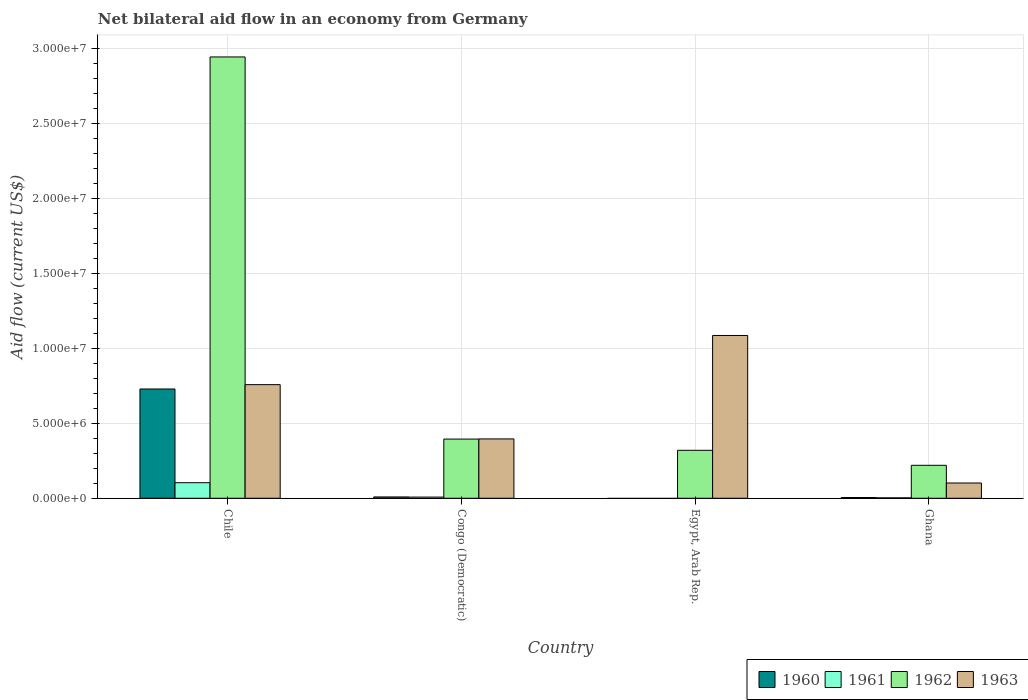How many different coloured bars are there?
Make the answer very short. 4. Are the number of bars per tick equal to the number of legend labels?
Offer a very short reply. No. How many bars are there on the 4th tick from the left?
Provide a succinct answer. 4. How many bars are there on the 1st tick from the right?
Ensure brevity in your answer.  4. What is the label of the 2nd group of bars from the left?
Offer a terse response. Congo (Democratic). What is the net bilateral aid flow in 1963 in Congo (Democratic)?
Your answer should be compact. 3.96e+06. Across all countries, what is the maximum net bilateral aid flow in 1962?
Your answer should be compact. 2.94e+07. Across all countries, what is the minimum net bilateral aid flow in 1963?
Your answer should be compact. 1.02e+06. What is the total net bilateral aid flow in 1960 in the graph?
Ensure brevity in your answer.  7.43e+06. What is the difference between the net bilateral aid flow in 1963 in Egypt, Arab Rep. and that in Ghana?
Offer a very short reply. 9.84e+06. What is the difference between the net bilateral aid flow in 1961 in Egypt, Arab Rep. and the net bilateral aid flow in 1963 in Ghana?
Make the answer very short. -1.02e+06. What is the average net bilateral aid flow in 1960 per country?
Your answer should be very brief. 1.86e+06. What is the difference between the net bilateral aid flow of/in 1962 and net bilateral aid flow of/in 1963 in Chile?
Your answer should be very brief. 2.19e+07. What is the ratio of the net bilateral aid flow in 1963 in Chile to that in Egypt, Arab Rep.?
Offer a very short reply. 0.7. Is the net bilateral aid flow in 1962 in Chile less than that in Congo (Democratic)?
Your answer should be compact. No. What is the difference between the highest and the second highest net bilateral aid flow in 1962?
Give a very brief answer. 2.62e+07. What is the difference between the highest and the lowest net bilateral aid flow in 1963?
Keep it short and to the point. 9.84e+06. In how many countries, is the net bilateral aid flow in 1960 greater than the average net bilateral aid flow in 1960 taken over all countries?
Ensure brevity in your answer.  1. Is it the case that in every country, the sum of the net bilateral aid flow in 1963 and net bilateral aid flow in 1961 is greater than the net bilateral aid flow in 1962?
Provide a succinct answer. No. How many bars are there?
Keep it short and to the point. 14. What is the difference between two consecutive major ticks on the Y-axis?
Offer a terse response. 5.00e+06. Are the values on the major ticks of Y-axis written in scientific E-notation?
Your response must be concise. Yes. Does the graph contain any zero values?
Offer a terse response. Yes. Does the graph contain grids?
Make the answer very short. Yes. What is the title of the graph?
Offer a very short reply. Net bilateral aid flow in an economy from Germany. What is the label or title of the Y-axis?
Provide a short and direct response. Aid flow (current US$). What is the Aid flow (current US$) in 1960 in Chile?
Keep it short and to the point. 7.29e+06. What is the Aid flow (current US$) in 1961 in Chile?
Keep it short and to the point. 1.04e+06. What is the Aid flow (current US$) in 1962 in Chile?
Provide a succinct answer. 2.94e+07. What is the Aid flow (current US$) in 1963 in Chile?
Offer a very short reply. 7.58e+06. What is the Aid flow (current US$) of 1962 in Congo (Democratic)?
Your answer should be compact. 3.95e+06. What is the Aid flow (current US$) in 1963 in Congo (Democratic)?
Keep it short and to the point. 3.96e+06. What is the Aid flow (current US$) in 1960 in Egypt, Arab Rep.?
Give a very brief answer. 0. What is the Aid flow (current US$) of 1961 in Egypt, Arab Rep.?
Give a very brief answer. 0. What is the Aid flow (current US$) of 1962 in Egypt, Arab Rep.?
Ensure brevity in your answer.  3.20e+06. What is the Aid flow (current US$) in 1963 in Egypt, Arab Rep.?
Your answer should be compact. 1.09e+07. What is the Aid flow (current US$) in 1961 in Ghana?
Provide a succinct answer. 3.00e+04. What is the Aid flow (current US$) in 1962 in Ghana?
Give a very brief answer. 2.20e+06. What is the Aid flow (current US$) of 1963 in Ghana?
Provide a succinct answer. 1.02e+06. Across all countries, what is the maximum Aid flow (current US$) of 1960?
Keep it short and to the point. 7.29e+06. Across all countries, what is the maximum Aid flow (current US$) of 1961?
Offer a very short reply. 1.04e+06. Across all countries, what is the maximum Aid flow (current US$) of 1962?
Give a very brief answer. 2.94e+07. Across all countries, what is the maximum Aid flow (current US$) of 1963?
Offer a very short reply. 1.09e+07. Across all countries, what is the minimum Aid flow (current US$) in 1961?
Keep it short and to the point. 0. Across all countries, what is the minimum Aid flow (current US$) of 1962?
Keep it short and to the point. 2.20e+06. Across all countries, what is the minimum Aid flow (current US$) of 1963?
Make the answer very short. 1.02e+06. What is the total Aid flow (current US$) in 1960 in the graph?
Offer a very short reply. 7.43e+06. What is the total Aid flow (current US$) of 1961 in the graph?
Provide a succinct answer. 1.15e+06. What is the total Aid flow (current US$) of 1962 in the graph?
Ensure brevity in your answer.  3.88e+07. What is the total Aid flow (current US$) of 1963 in the graph?
Provide a short and direct response. 2.34e+07. What is the difference between the Aid flow (current US$) in 1960 in Chile and that in Congo (Democratic)?
Your answer should be very brief. 7.20e+06. What is the difference between the Aid flow (current US$) of 1961 in Chile and that in Congo (Democratic)?
Your answer should be very brief. 9.60e+05. What is the difference between the Aid flow (current US$) in 1962 in Chile and that in Congo (Democratic)?
Your answer should be very brief. 2.55e+07. What is the difference between the Aid flow (current US$) in 1963 in Chile and that in Congo (Democratic)?
Keep it short and to the point. 3.62e+06. What is the difference between the Aid flow (current US$) in 1962 in Chile and that in Egypt, Arab Rep.?
Your answer should be compact. 2.62e+07. What is the difference between the Aid flow (current US$) in 1963 in Chile and that in Egypt, Arab Rep.?
Your response must be concise. -3.28e+06. What is the difference between the Aid flow (current US$) in 1960 in Chile and that in Ghana?
Offer a very short reply. 7.24e+06. What is the difference between the Aid flow (current US$) in 1961 in Chile and that in Ghana?
Provide a succinct answer. 1.01e+06. What is the difference between the Aid flow (current US$) of 1962 in Chile and that in Ghana?
Keep it short and to the point. 2.72e+07. What is the difference between the Aid flow (current US$) in 1963 in Chile and that in Ghana?
Your answer should be compact. 6.56e+06. What is the difference between the Aid flow (current US$) in 1962 in Congo (Democratic) and that in Egypt, Arab Rep.?
Your answer should be very brief. 7.50e+05. What is the difference between the Aid flow (current US$) in 1963 in Congo (Democratic) and that in Egypt, Arab Rep.?
Provide a short and direct response. -6.90e+06. What is the difference between the Aid flow (current US$) of 1960 in Congo (Democratic) and that in Ghana?
Your answer should be very brief. 4.00e+04. What is the difference between the Aid flow (current US$) in 1961 in Congo (Democratic) and that in Ghana?
Offer a very short reply. 5.00e+04. What is the difference between the Aid flow (current US$) in 1962 in Congo (Democratic) and that in Ghana?
Provide a succinct answer. 1.75e+06. What is the difference between the Aid flow (current US$) in 1963 in Congo (Democratic) and that in Ghana?
Provide a short and direct response. 2.94e+06. What is the difference between the Aid flow (current US$) in 1962 in Egypt, Arab Rep. and that in Ghana?
Provide a succinct answer. 1.00e+06. What is the difference between the Aid flow (current US$) in 1963 in Egypt, Arab Rep. and that in Ghana?
Your answer should be compact. 9.84e+06. What is the difference between the Aid flow (current US$) of 1960 in Chile and the Aid flow (current US$) of 1961 in Congo (Democratic)?
Make the answer very short. 7.21e+06. What is the difference between the Aid flow (current US$) in 1960 in Chile and the Aid flow (current US$) in 1962 in Congo (Democratic)?
Your response must be concise. 3.34e+06. What is the difference between the Aid flow (current US$) in 1960 in Chile and the Aid flow (current US$) in 1963 in Congo (Democratic)?
Ensure brevity in your answer.  3.33e+06. What is the difference between the Aid flow (current US$) in 1961 in Chile and the Aid flow (current US$) in 1962 in Congo (Democratic)?
Provide a succinct answer. -2.91e+06. What is the difference between the Aid flow (current US$) of 1961 in Chile and the Aid flow (current US$) of 1963 in Congo (Democratic)?
Provide a succinct answer. -2.92e+06. What is the difference between the Aid flow (current US$) in 1962 in Chile and the Aid flow (current US$) in 1963 in Congo (Democratic)?
Offer a terse response. 2.55e+07. What is the difference between the Aid flow (current US$) in 1960 in Chile and the Aid flow (current US$) in 1962 in Egypt, Arab Rep.?
Give a very brief answer. 4.09e+06. What is the difference between the Aid flow (current US$) of 1960 in Chile and the Aid flow (current US$) of 1963 in Egypt, Arab Rep.?
Your answer should be very brief. -3.57e+06. What is the difference between the Aid flow (current US$) in 1961 in Chile and the Aid flow (current US$) in 1962 in Egypt, Arab Rep.?
Your answer should be very brief. -2.16e+06. What is the difference between the Aid flow (current US$) in 1961 in Chile and the Aid flow (current US$) in 1963 in Egypt, Arab Rep.?
Give a very brief answer. -9.82e+06. What is the difference between the Aid flow (current US$) in 1962 in Chile and the Aid flow (current US$) in 1963 in Egypt, Arab Rep.?
Make the answer very short. 1.86e+07. What is the difference between the Aid flow (current US$) of 1960 in Chile and the Aid flow (current US$) of 1961 in Ghana?
Your response must be concise. 7.26e+06. What is the difference between the Aid flow (current US$) in 1960 in Chile and the Aid flow (current US$) in 1962 in Ghana?
Your answer should be very brief. 5.09e+06. What is the difference between the Aid flow (current US$) of 1960 in Chile and the Aid flow (current US$) of 1963 in Ghana?
Provide a short and direct response. 6.27e+06. What is the difference between the Aid flow (current US$) of 1961 in Chile and the Aid flow (current US$) of 1962 in Ghana?
Make the answer very short. -1.16e+06. What is the difference between the Aid flow (current US$) of 1961 in Chile and the Aid flow (current US$) of 1963 in Ghana?
Offer a very short reply. 2.00e+04. What is the difference between the Aid flow (current US$) in 1962 in Chile and the Aid flow (current US$) in 1963 in Ghana?
Your response must be concise. 2.84e+07. What is the difference between the Aid flow (current US$) of 1960 in Congo (Democratic) and the Aid flow (current US$) of 1962 in Egypt, Arab Rep.?
Provide a succinct answer. -3.11e+06. What is the difference between the Aid flow (current US$) in 1960 in Congo (Democratic) and the Aid flow (current US$) in 1963 in Egypt, Arab Rep.?
Your answer should be compact. -1.08e+07. What is the difference between the Aid flow (current US$) of 1961 in Congo (Democratic) and the Aid flow (current US$) of 1962 in Egypt, Arab Rep.?
Your response must be concise. -3.12e+06. What is the difference between the Aid flow (current US$) of 1961 in Congo (Democratic) and the Aid flow (current US$) of 1963 in Egypt, Arab Rep.?
Make the answer very short. -1.08e+07. What is the difference between the Aid flow (current US$) of 1962 in Congo (Democratic) and the Aid flow (current US$) of 1963 in Egypt, Arab Rep.?
Provide a short and direct response. -6.91e+06. What is the difference between the Aid flow (current US$) of 1960 in Congo (Democratic) and the Aid flow (current US$) of 1961 in Ghana?
Keep it short and to the point. 6.00e+04. What is the difference between the Aid flow (current US$) in 1960 in Congo (Democratic) and the Aid flow (current US$) in 1962 in Ghana?
Ensure brevity in your answer.  -2.11e+06. What is the difference between the Aid flow (current US$) of 1960 in Congo (Democratic) and the Aid flow (current US$) of 1963 in Ghana?
Your response must be concise. -9.30e+05. What is the difference between the Aid flow (current US$) in 1961 in Congo (Democratic) and the Aid flow (current US$) in 1962 in Ghana?
Your response must be concise. -2.12e+06. What is the difference between the Aid flow (current US$) in 1961 in Congo (Democratic) and the Aid flow (current US$) in 1963 in Ghana?
Your answer should be compact. -9.40e+05. What is the difference between the Aid flow (current US$) of 1962 in Congo (Democratic) and the Aid flow (current US$) of 1963 in Ghana?
Your answer should be compact. 2.93e+06. What is the difference between the Aid flow (current US$) of 1962 in Egypt, Arab Rep. and the Aid flow (current US$) of 1963 in Ghana?
Make the answer very short. 2.18e+06. What is the average Aid flow (current US$) in 1960 per country?
Offer a very short reply. 1.86e+06. What is the average Aid flow (current US$) in 1961 per country?
Offer a very short reply. 2.88e+05. What is the average Aid flow (current US$) in 1962 per country?
Your response must be concise. 9.70e+06. What is the average Aid flow (current US$) of 1963 per country?
Ensure brevity in your answer.  5.86e+06. What is the difference between the Aid flow (current US$) in 1960 and Aid flow (current US$) in 1961 in Chile?
Your answer should be very brief. 6.25e+06. What is the difference between the Aid flow (current US$) in 1960 and Aid flow (current US$) in 1962 in Chile?
Offer a very short reply. -2.22e+07. What is the difference between the Aid flow (current US$) in 1960 and Aid flow (current US$) in 1963 in Chile?
Provide a succinct answer. -2.90e+05. What is the difference between the Aid flow (current US$) of 1961 and Aid flow (current US$) of 1962 in Chile?
Offer a terse response. -2.84e+07. What is the difference between the Aid flow (current US$) of 1961 and Aid flow (current US$) of 1963 in Chile?
Ensure brevity in your answer.  -6.54e+06. What is the difference between the Aid flow (current US$) of 1962 and Aid flow (current US$) of 1963 in Chile?
Provide a short and direct response. 2.19e+07. What is the difference between the Aid flow (current US$) of 1960 and Aid flow (current US$) of 1961 in Congo (Democratic)?
Make the answer very short. 10000. What is the difference between the Aid flow (current US$) of 1960 and Aid flow (current US$) of 1962 in Congo (Democratic)?
Your answer should be compact. -3.86e+06. What is the difference between the Aid flow (current US$) in 1960 and Aid flow (current US$) in 1963 in Congo (Democratic)?
Ensure brevity in your answer.  -3.87e+06. What is the difference between the Aid flow (current US$) of 1961 and Aid flow (current US$) of 1962 in Congo (Democratic)?
Make the answer very short. -3.87e+06. What is the difference between the Aid flow (current US$) of 1961 and Aid flow (current US$) of 1963 in Congo (Democratic)?
Keep it short and to the point. -3.88e+06. What is the difference between the Aid flow (current US$) of 1962 and Aid flow (current US$) of 1963 in Congo (Democratic)?
Offer a terse response. -10000. What is the difference between the Aid flow (current US$) of 1962 and Aid flow (current US$) of 1963 in Egypt, Arab Rep.?
Keep it short and to the point. -7.66e+06. What is the difference between the Aid flow (current US$) in 1960 and Aid flow (current US$) in 1962 in Ghana?
Keep it short and to the point. -2.15e+06. What is the difference between the Aid flow (current US$) of 1960 and Aid flow (current US$) of 1963 in Ghana?
Give a very brief answer. -9.70e+05. What is the difference between the Aid flow (current US$) of 1961 and Aid flow (current US$) of 1962 in Ghana?
Provide a succinct answer. -2.17e+06. What is the difference between the Aid flow (current US$) of 1961 and Aid flow (current US$) of 1963 in Ghana?
Give a very brief answer. -9.90e+05. What is the difference between the Aid flow (current US$) of 1962 and Aid flow (current US$) of 1963 in Ghana?
Give a very brief answer. 1.18e+06. What is the ratio of the Aid flow (current US$) of 1962 in Chile to that in Congo (Democratic)?
Provide a succinct answer. 7.45. What is the ratio of the Aid flow (current US$) in 1963 in Chile to that in Congo (Democratic)?
Your response must be concise. 1.91. What is the ratio of the Aid flow (current US$) of 1962 in Chile to that in Egypt, Arab Rep.?
Keep it short and to the point. 9.2. What is the ratio of the Aid flow (current US$) in 1963 in Chile to that in Egypt, Arab Rep.?
Your answer should be compact. 0.7. What is the ratio of the Aid flow (current US$) of 1960 in Chile to that in Ghana?
Your answer should be very brief. 145.8. What is the ratio of the Aid flow (current US$) in 1961 in Chile to that in Ghana?
Keep it short and to the point. 34.67. What is the ratio of the Aid flow (current US$) of 1962 in Chile to that in Ghana?
Offer a terse response. 13.38. What is the ratio of the Aid flow (current US$) of 1963 in Chile to that in Ghana?
Keep it short and to the point. 7.43. What is the ratio of the Aid flow (current US$) of 1962 in Congo (Democratic) to that in Egypt, Arab Rep.?
Give a very brief answer. 1.23. What is the ratio of the Aid flow (current US$) in 1963 in Congo (Democratic) to that in Egypt, Arab Rep.?
Ensure brevity in your answer.  0.36. What is the ratio of the Aid flow (current US$) in 1961 in Congo (Democratic) to that in Ghana?
Your answer should be compact. 2.67. What is the ratio of the Aid flow (current US$) of 1962 in Congo (Democratic) to that in Ghana?
Provide a short and direct response. 1.8. What is the ratio of the Aid flow (current US$) in 1963 in Congo (Democratic) to that in Ghana?
Offer a terse response. 3.88. What is the ratio of the Aid flow (current US$) in 1962 in Egypt, Arab Rep. to that in Ghana?
Offer a very short reply. 1.45. What is the ratio of the Aid flow (current US$) in 1963 in Egypt, Arab Rep. to that in Ghana?
Give a very brief answer. 10.65. What is the difference between the highest and the second highest Aid flow (current US$) in 1960?
Provide a succinct answer. 7.20e+06. What is the difference between the highest and the second highest Aid flow (current US$) in 1961?
Provide a succinct answer. 9.60e+05. What is the difference between the highest and the second highest Aid flow (current US$) of 1962?
Your answer should be compact. 2.55e+07. What is the difference between the highest and the second highest Aid flow (current US$) in 1963?
Provide a short and direct response. 3.28e+06. What is the difference between the highest and the lowest Aid flow (current US$) of 1960?
Offer a very short reply. 7.29e+06. What is the difference between the highest and the lowest Aid flow (current US$) in 1961?
Provide a succinct answer. 1.04e+06. What is the difference between the highest and the lowest Aid flow (current US$) in 1962?
Offer a terse response. 2.72e+07. What is the difference between the highest and the lowest Aid flow (current US$) in 1963?
Your answer should be very brief. 9.84e+06. 